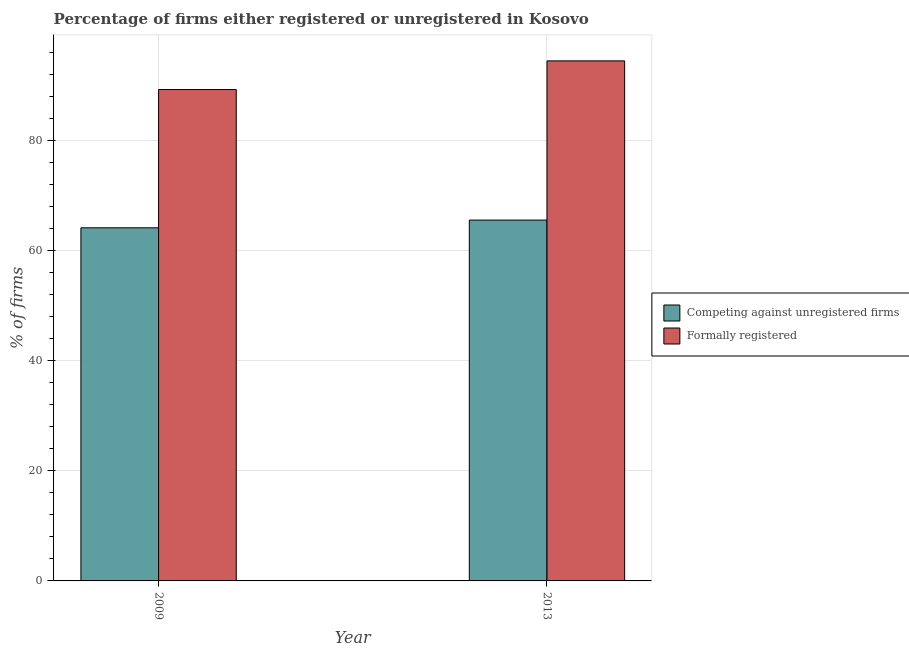How many different coloured bars are there?
Offer a very short reply. 2. Are the number of bars per tick equal to the number of legend labels?
Ensure brevity in your answer.  Yes. How many bars are there on the 2nd tick from the left?
Ensure brevity in your answer.  2. What is the label of the 1st group of bars from the left?
Your answer should be compact. 2009. In how many cases, is the number of bars for a given year not equal to the number of legend labels?
Your response must be concise. 0. What is the percentage of registered firms in 2009?
Make the answer very short. 64.1. Across all years, what is the maximum percentage of registered firms?
Give a very brief answer. 65.5. Across all years, what is the minimum percentage of registered firms?
Your answer should be very brief. 64.1. What is the total percentage of formally registered firms in the graph?
Keep it short and to the point. 183.6. What is the difference between the percentage of registered firms in 2009 and that in 2013?
Offer a terse response. -1.4. What is the difference between the percentage of registered firms in 2009 and the percentage of formally registered firms in 2013?
Offer a terse response. -1.4. What is the average percentage of registered firms per year?
Offer a very short reply. 64.8. In the year 2013, what is the difference between the percentage of formally registered firms and percentage of registered firms?
Your answer should be compact. 0. What is the ratio of the percentage of formally registered firms in 2009 to that in 2013?
Make the answer very short. 0.94. In how many years, is the percentage of formally registered firms greater than the average percentage of formally registered firms taken over all years?
Offer a very short reply. 1. What does the 1st bar from the left in 2013 represents?
Offer a very short reply. Competing against unregistered firms. What does the 1st bar from the right in 2009 represents?
Provide a short and direct response. Formally registered. How many bars are there?
Provide a succinct answer. 4. Are all the bars in the graph horizontal?
Make the answer very short. No. How many years are there in the graph?
Provide a short and direct response. 2. Are the values on the major ticks of Y-axis written in scientific E-notation?
Your answer should be compact. No. How many legend labels are there?
Your answer should be very brief. 2. What is the title of the graph?
Provide a short and direct response. Percentage of firms either registered or unregistered in Kosovo. Does "Travel Items" appear as one of the legend labels in the graph?
Make the answer very short. No. What is the label or title of the X-axis?
Provide a short and direct response. Year. What is the label or title of the Y-axis?
Ensure brevity in your answer.  % of firms. What is the % of firms in Competing against unregistered firms in 2009?
Keep it short and to the point. 64.1. What is the % of firms in Formally registered in 2009?
Give a very brief answer. 89.2. What is the % of firms of Competing against unregistered firms in 2013?
Ensure brevity in your answer.  65.5. What is the % of firms in Formally registered in 2013?
Offer a very short reply. 94.4. Across all years, what is the maximum % of firms of Competing against unregistered firms?
Keep it short and to the point. 65.5. Across all years, what is the maximum % of firms in Formally registered?
Offer a very short reply. 94.4. Across all years, what is the minimum % of firms in Competing against unregistered firms?
Your answer should be compact. 64.1. Across all years, what is the minimum % of firms in Formally registered?
Ensure brevity in your answer.  89.2. What is the total % of firms of Competing against unregistered firms in the graph?
Provide a short and direct response. 129.6. What is the total % of firms of Formally registered in the graph?
Keep it short and to the point. 183.6. What is the difference between the % of firms in Competing against unregistered firms in 2009 and that in 2013?
Give a very brief answer. -1.4. What is the difference between the % of firms in Competing against unregistered firms in 2009 and the % of firms in Formally registered in 2013?
Offer a very short reply. -30.3. What is the average % of firms in Competing against unregistered firms per year?
Give a very brief answer. 64.8. What is the average % of firms in Formally registered per year?
Offer a very short reply. 91.8. In the year 2009, what is the difference between the % of firms in Competing against unregistered firms and % of firms in Formally registered?
Make the answer very short. -25.1. In the year 2013, what is the difference between the % of firms of Competing against unregistered firms and % of firms of Formally registered?
Offer a very short reply. -28.9. What is the ratio of the % of firms in Competing against unregistered firms in 2009 to that in 2013?
Ensure brevity in your answer.  0.98. What is the ratio of the % of firms in Formally registered in 2009 to that in 2013?
Provide a short and direct response. 0.94. What is the difference between the highest and the second highest % of firms in Competing against unregistered firms?
Your answer should be compact. 1.4. What is the difference between the highest and the second highest % of firms of Formally registered?
Keep it short and to the point. 5.2. 